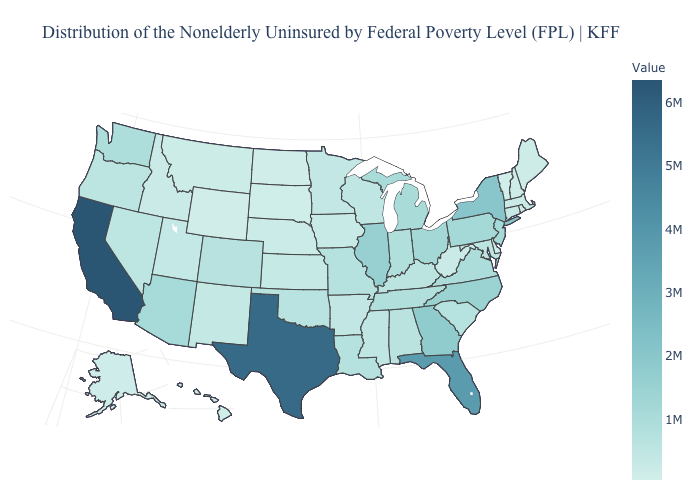Which states hav the highest value in the West?
Write a very short answer. California. Does New Jersey have the highest value in the USA?
Short answer required. No. Which states have the highest value in the USA?
Be succinct. California. Which states have the lowest value in the Northeast?
Answer briefly. Vermont. Is the legend a continuous bar?
Concise answer only. Yes. Among the states that border Pennsylvania , which have the highest value?
Write a very short answer. New York. Among the states that border Massachusetts , does Vermont have the lowest value?
Be succinct. Yes. 